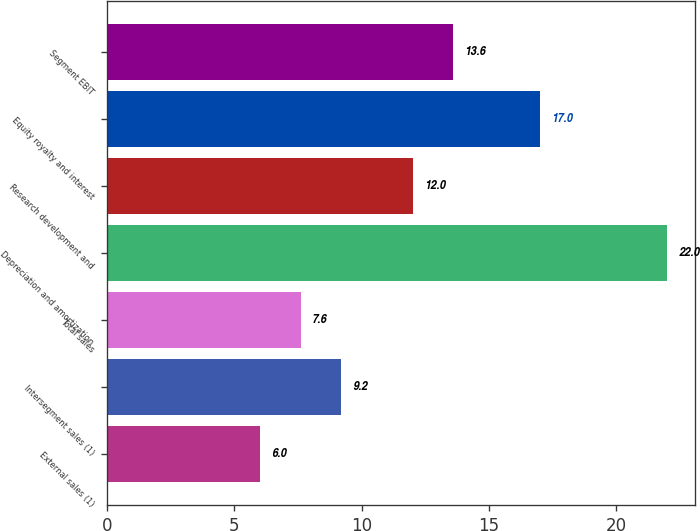Convert chart. <chart><loc_0><loc_0><loc_500><loc_500><bar_chart><fcel>External sales (1)<fcel>Intersegment sales (1)<fcel>Total sales<fcel>Depreciation and amortization<fcel>Research development and<fcel>Equity royalty and interest<fcel>Segment EBIT<nl><fcel>6<fcel>9.2<fcel>7.6<fcel>22<fcel>12<fcel>17<fcel>13.6<nl></chart> 